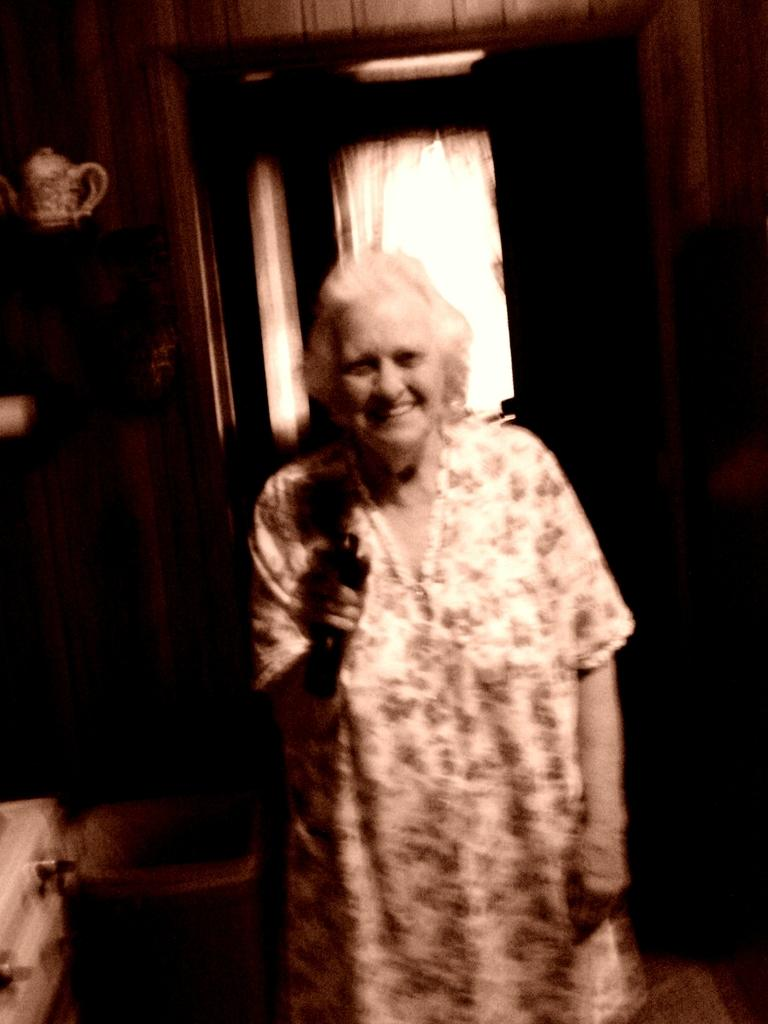Who is present in the image? There is a woman in the image. What is the woman holding in the image? The woman is holding an object. What can be seen in the image besides the woman? There is a kettle in the image. What is visible in the background of the image? The background of the image is dark. How many jellyfish can be seen swimming in the image? There are no jellyfish present in the image. What type of face is visible on the woman's leg in the image? There is no face visible on the woman's leg in the image. 